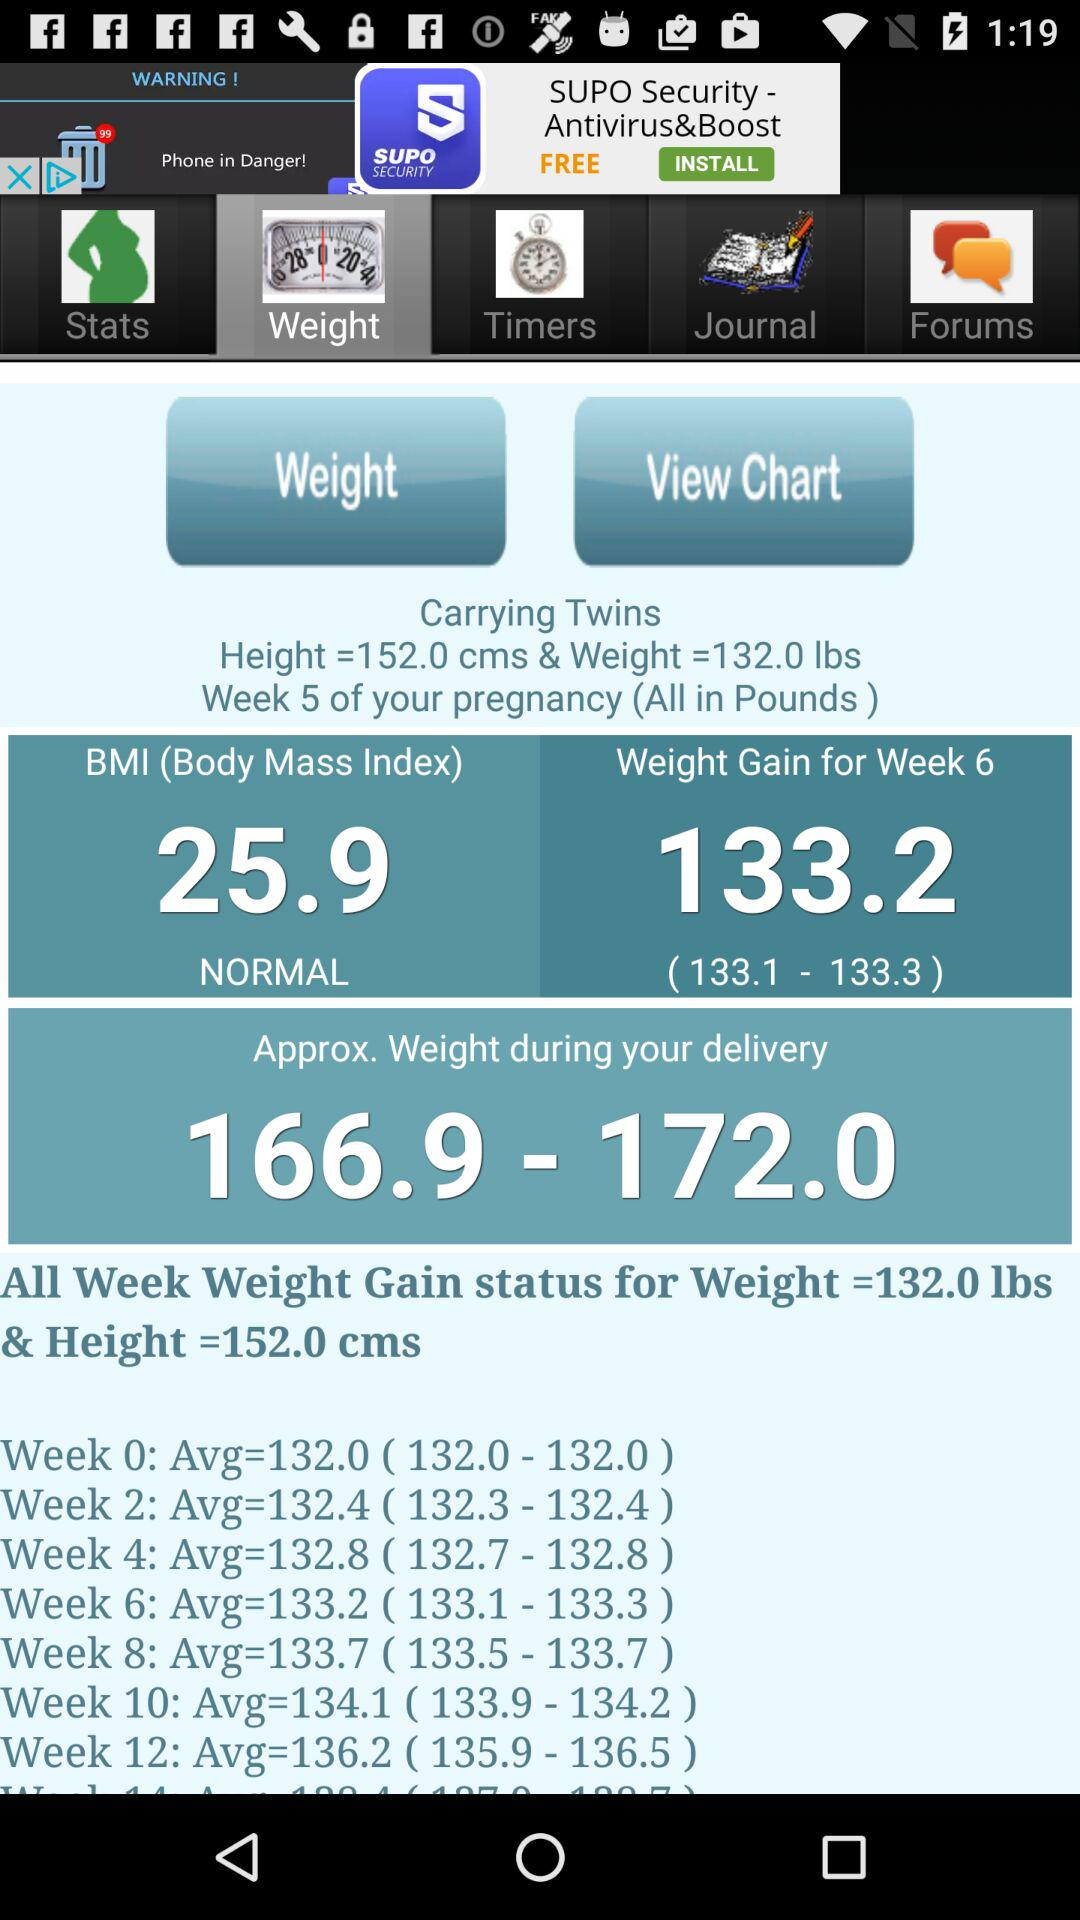What is the difference between the weight gain for week 6 and the weight gain for week 0?
Answer the question using a single word or phrase. 1.2 